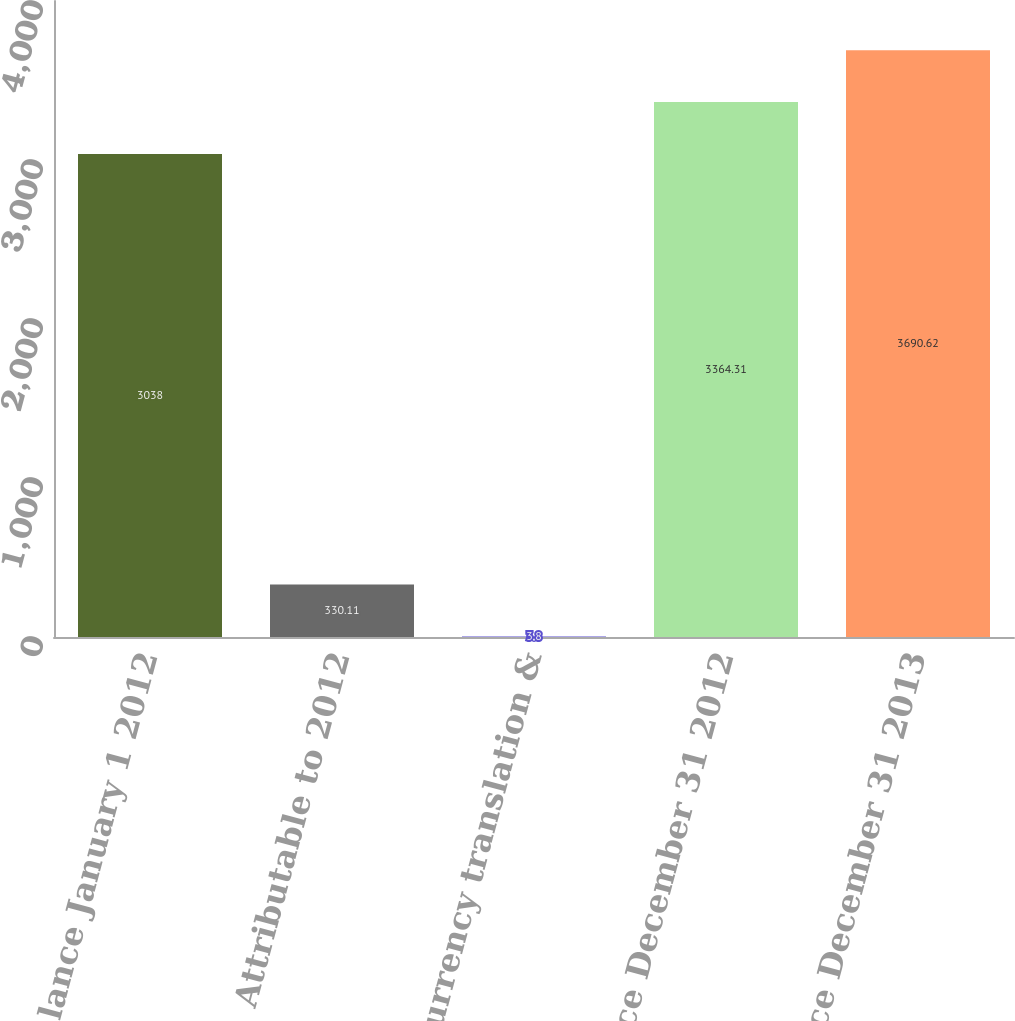Convert chart. <chart><loc_0><loc_0><loc_500><loc_500><bar_chart><fcel>Balance January 1 2012<fcel>Attributable to 2012<fcel>Foreign currency translation &<fcel>Balance December 31 2012<fcel>Balance December 31 2013<nl><fcel>3038<fcel>330.11<fcel>3.8<fcel>3364.31<fcel>3690.62<nl></chart> 